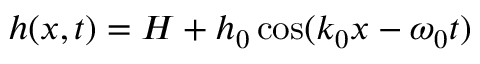Convert formula to latex. <formula><loc_0><loc_0><loc_500><loc_500>h ( x , t ) = H + h _ { 0 } \cos ( k _ { 0 } x - \omega _ { 0 } t )</formula> 